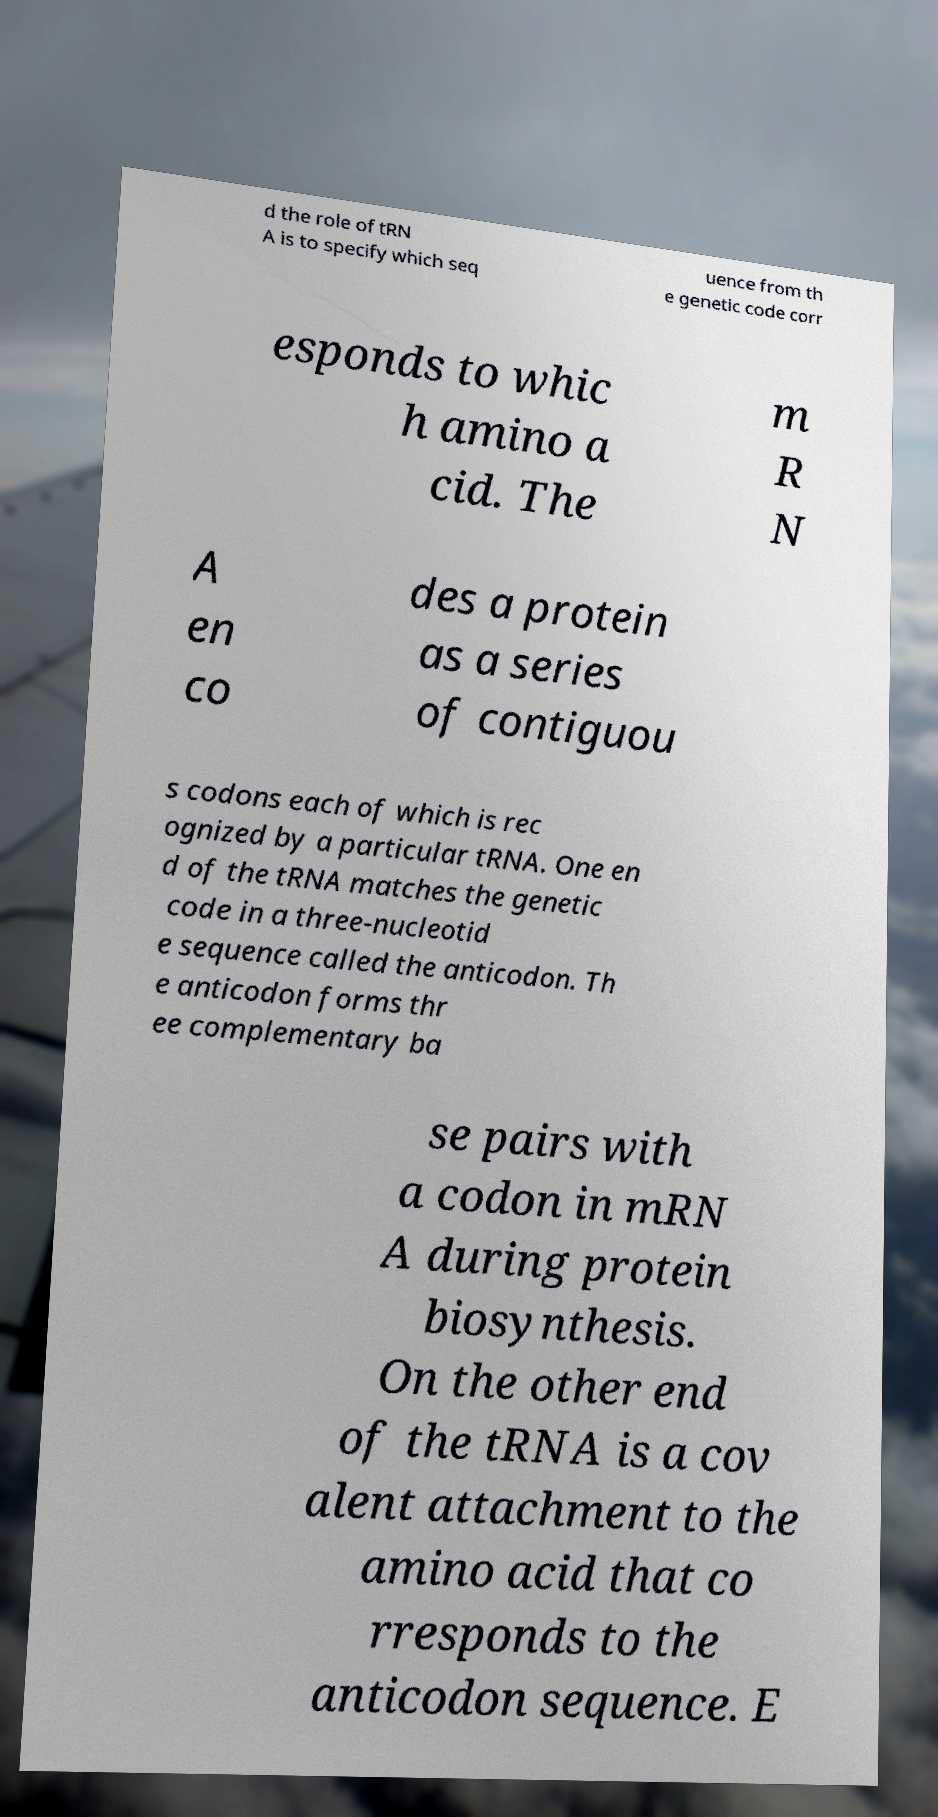Please read and relay the text visible in this image. What does it say? d the role of tRN A is to specify which seq uence from th e genetic code corr esponds to whic h amino a cid. The m R N A en co des a protein as a series of contiguou s codons each of which is rec ognized by a particular tRNA. One en d of the tRNA matches the genetic code in a three-nucleotid e sequence called the anticodon. Th e anticodon forms thr ee complementary ba se pairs with a codon in mRN A during protein biosynthesis. On the other end of the tRNA is a cov alent attachment to the amino acid that co rresponds to the anticodon sequence. E 